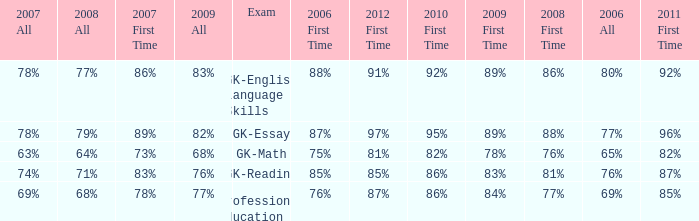What is the percentage for first time 2011 when the first time in 2009 is 68%? 82%. 